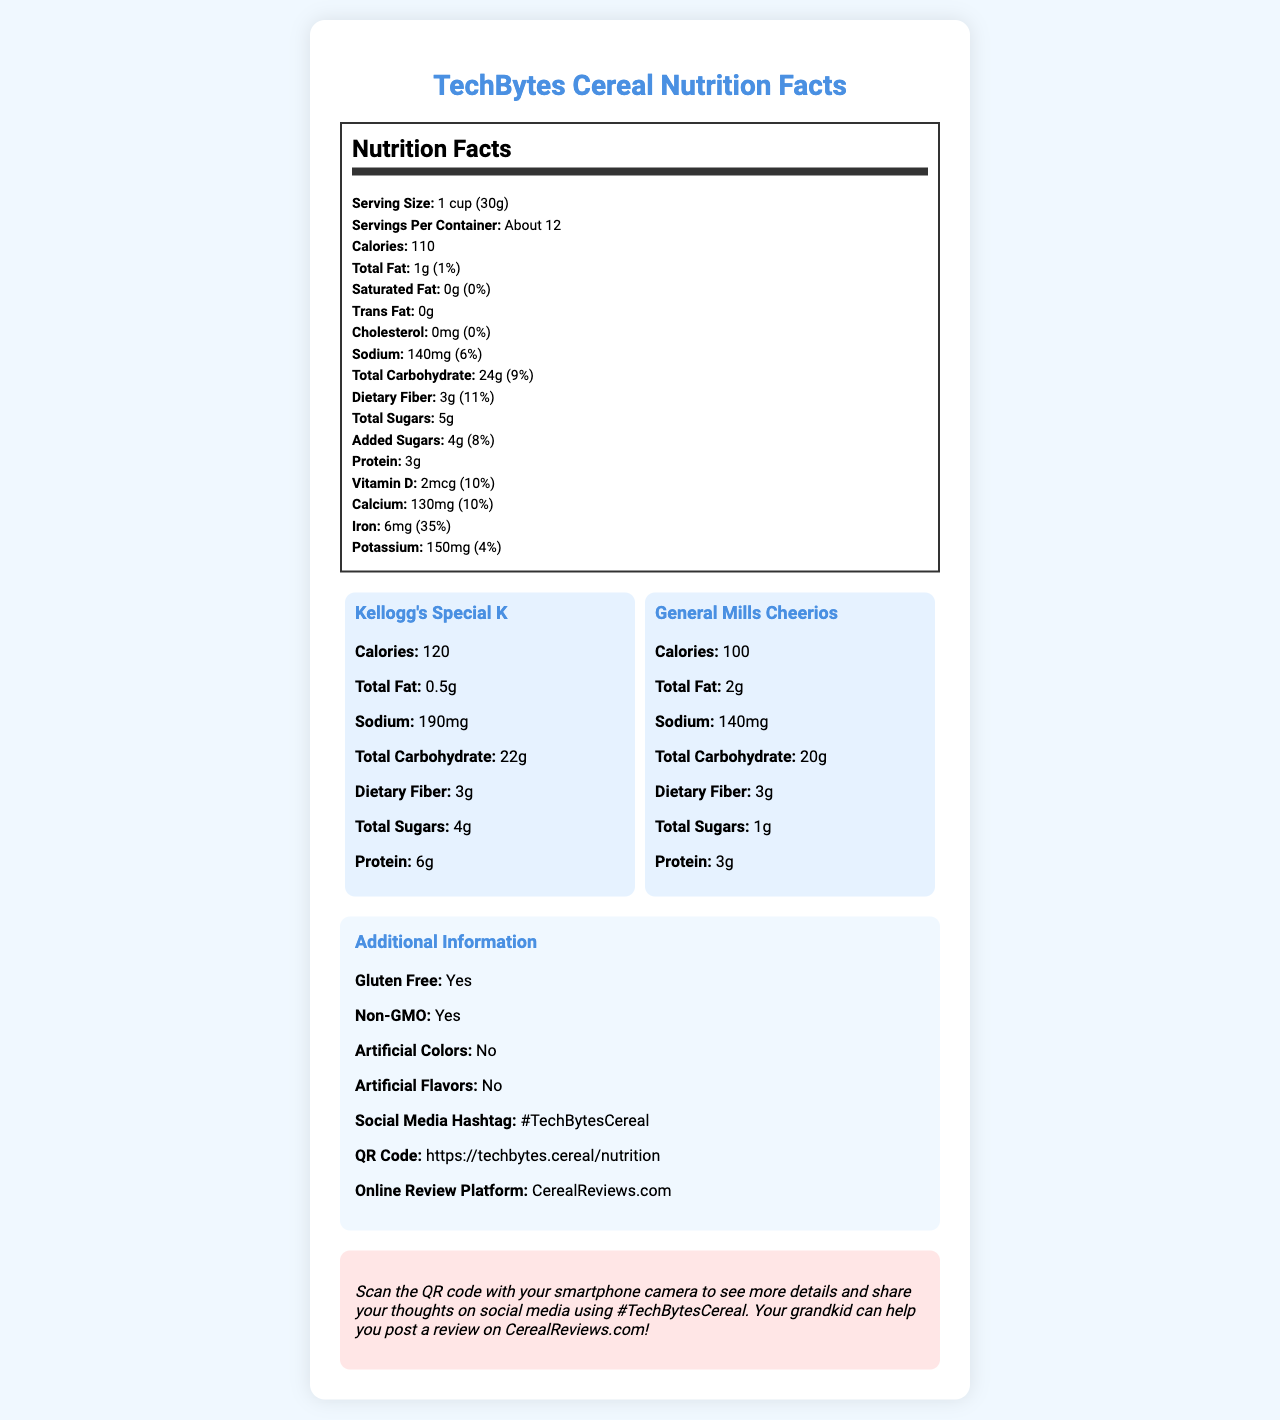what is the serving size of TechBytes Cereal? The serving size is specified as "1 cup (30g)" in the Nutrition Facts label.
Answer: 1 cup (30g) how many calories are in one serving of TechBytes Cereal? The Nutrition Facts label states that there are 110 calories per serving.
Answer: 110 compare the total fat content between TechBytes Cereal and Kellogg's Special K. The Nutrition Facts label and comparison section reveal that TechBytes Cereal has 1g of total fat, while Kellogg's Special K has 0.5g.
Answer: TechBytes Cereal: 1g, Kellogg's Special K: 0.5g what is the daily value percentage of iron in TechBytes Cereal? The Nutrition Facts label indicates that TechBytes Cereal provides 35% of the daily value for iron.
Answer: 35% how much protein does TechBytes Cereal have compared to General Mills Cheerios? The comparison section shows that both TechBytes Cereal and General Mills Cheerios have 3g of protein per serving.
Answer: Both have 3g of protein. which brand has the highest sodium content? A. TechBytes Cereal B. Kellogg's Special K C. General Mills Cheerios Kellogg's Special K has 190mg of sodium, which is higher than TechBytes Cereal (140mg) and General Mills Cheerios (140mg).
Answer: B which brand has the lowest total sugars? 1. TechBytes Cereal 2. Kellogg's Special K 3. General Mills Cheerios General Mills Cheerios has 1g total sugars, which is lower than TechBytes Cereal (5g) and Kellogg's Special K (4g).
Answer: 3 is TechBytes Cereal gluten-free? The additional information section states that TechBytes Cereal is gluten-free.
Answer: Yes describe the main idea of the document. The document title and sections such as the Nutrition Facts, comparison with name-brand cereals, additional information, and the grandparent-friendly note all contribute to the main idea. It provides a comprehensive overview of the product's nutritional value and additional features.
Answer: The document provides nutritional information about TechBytes Cereal and compares it with two name-brand cereals. It highlights the serving size, calories, macronutrients, vitamins, and minerals. There is also information about additional features like being gluten-free and non-GMO, and a note for grandparents on accessing further details and reviews online. what are the main ingredients of TechBytes Cereal? The document does not provide information on the main ingredients of TechBytes Cereal.
Answer: Cannot be determined how many servings are in a container of TechBytes Cereal? The Nutrition Facts label indicates "About 12" servings per container.
Answer: About 12 